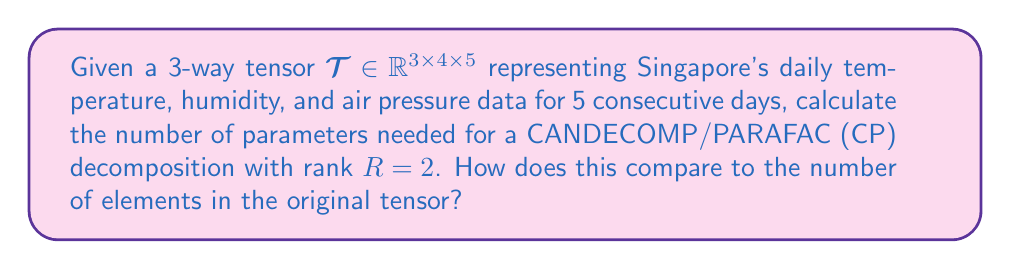Give your solution to this math problem. Let's approach this step-by-step:

1) The CP decomposition of a 3-way tensor $\mathcal{T} \in \mathbb{R}^{I_1 \times I_2 \times I_3}$ with rank $R$ is given by:

   $$\mathcal{T} \approx \sum_{r=1}^R a_r \circ b_r \circ c_r$$

   where $a_r \in \mathbb{R}^{I_1}$, $b_r \in \mathbb{R}^{I_2}$, and $c_r \in \mathbb{R}^{I_3}$ for $r = 1, ..., R$.

2) In our case, $I_1 = 3$ (temperature), $I_2 = 4$ (humidity), $I_3 = 5$ (air pressure), and $R = 2$.

3) For each $r$, we need:
   - 3 parameters for $a_r$
   - 4 parameters for $b_r$
   - 5 parameters for $c_r$

4) Total number of parameters for one component:
   $3 + 4 + 5 = 12$

5) Since we have $R = 2$ components, the total number of parameters is:
   $12 \times 2 = 24$

6) The number of elements in the original tensor is:
   $3 \times 4 \times 5 = 60$

7) Comparison:
   The CP decomposition uses 24 parameters, which is 40% of the original tensor's 60 elements.
Answer: 24 parameters; 40% of original 